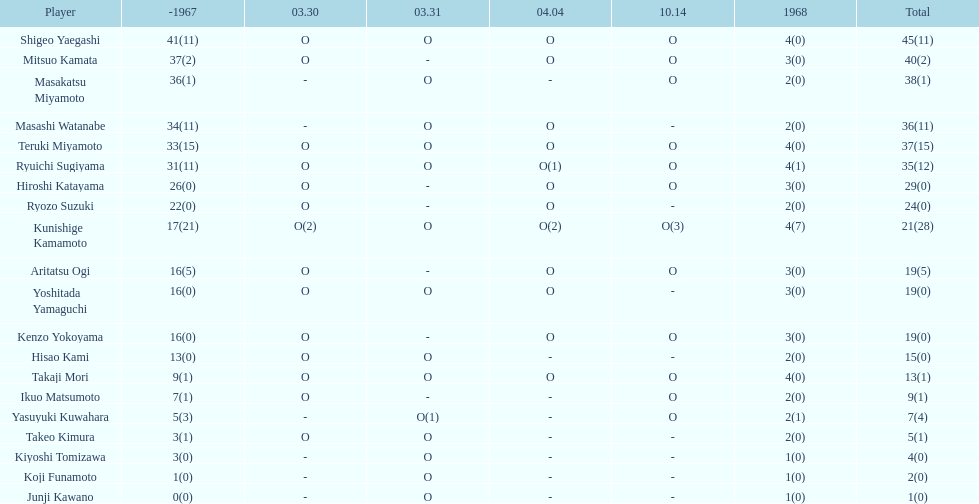By how many appearances does shigeo yaegashi's total surpass mitsuo kamata's total? 5. 